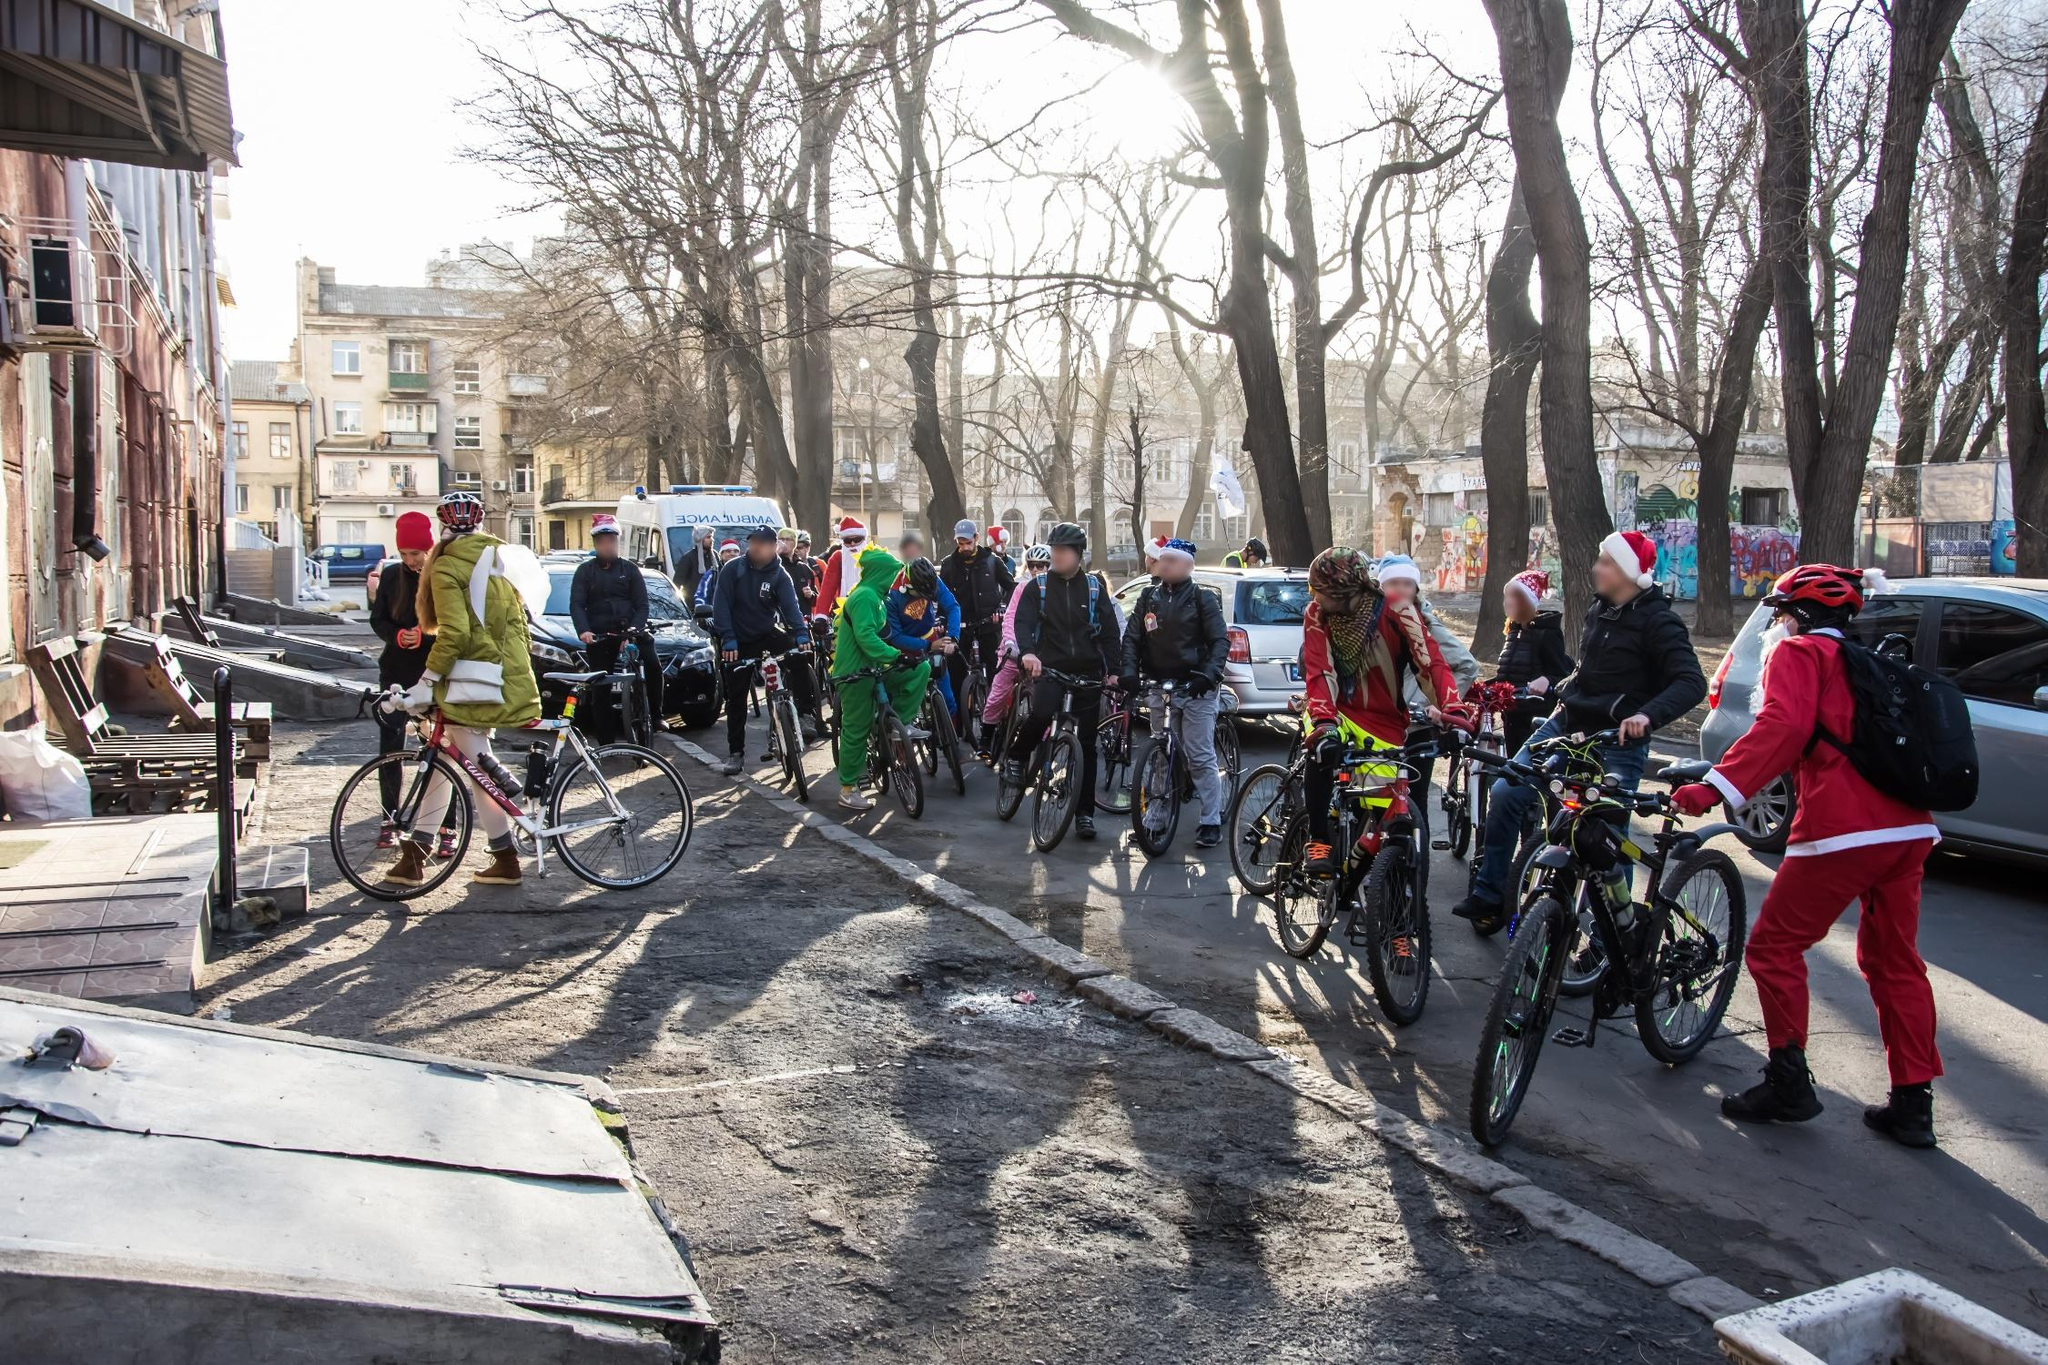What might be the purpose of this gathering? The gathering in the image appears to be centered around a festive cycling event. The costumes and festive attire of the participants suggest that this is likely a holiday celebration, possibly related to Christmas. Such events are often organized to promote community spirit, celebrate the festive season, and sometimes raise awareness or funds for charitable causes. The communal and playful nature of the attire, coupled with the preparation to embark on a group ride, all point towards a joyful and purposeful gathering aimed at bringing people together in celebration and possibly supporting a larger cause. 